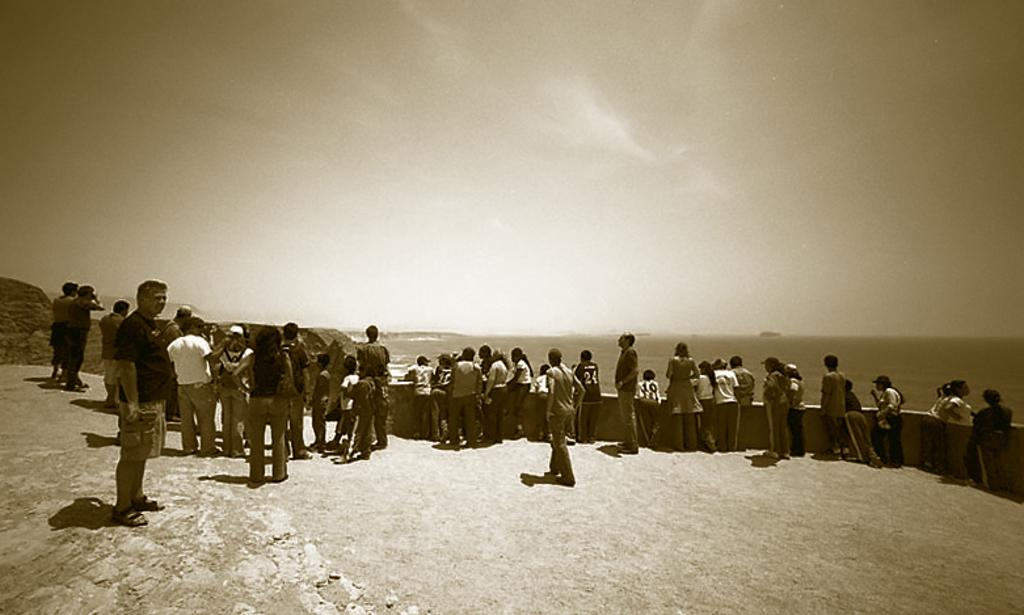What is happening in the image involving the people? The people are standing and looking at something. What can be seen in the background of the image? There is sky visible at the top of the image. What is the color scheme of the image? The image is black and white. Can you tell me how many dogs are present in the image? There are no dogs present in the image; it only features people standing and looking at something. What type of spring is visible in the image? There is no spring present in the image; it is a black and white image of people standing and looking at something with sky visible in the background. 